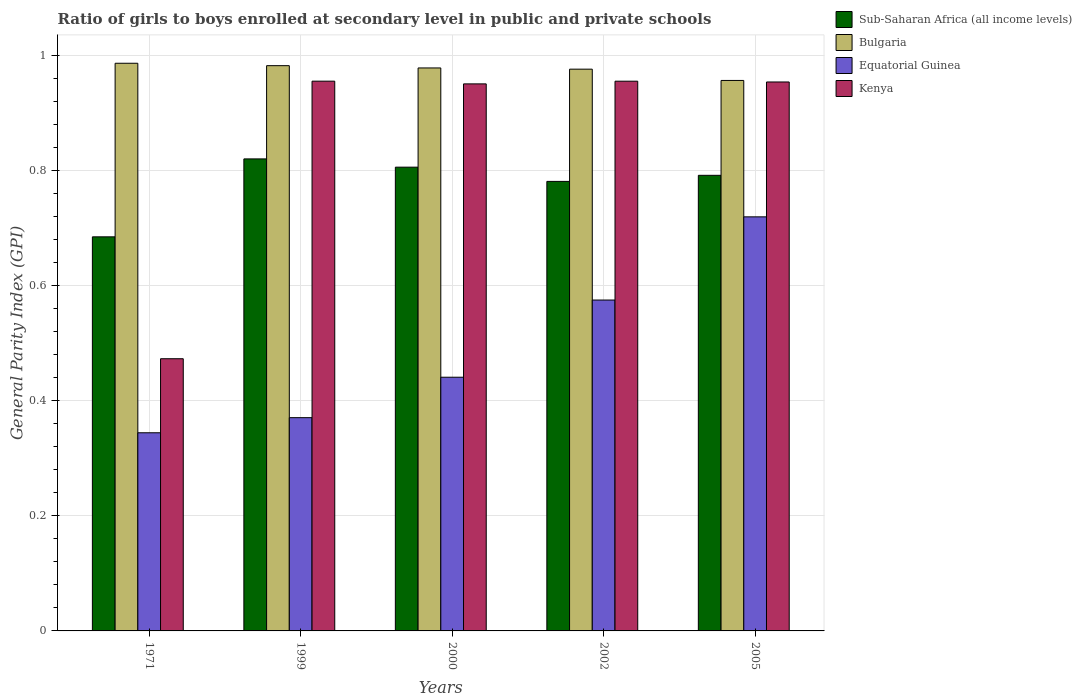Are the number of bars on each tick of the X-axis equal?
Offer a very short reply. Yes. How many bars are there on the 5th tick from the left?
Give a very brief answer. 4. How many bars are there on the 1st tick from the right?
Make the answer very short. 4. In how many cases, is the number of bars for a given year not equal to the number of legend labels?
Your response must be concise. 0. What is the general parity index in Equatorial Guinea in 2002?
Provide a short and direct response. 0.58. Across all years, what is the maximum general parity index in Sub-Saharan Africa (all income levels)?
Your answer should be compact. 0.82. Across all years, what is the minimum general parity index in Sub-Saharan Africa (all income levels)?
Your response must be concise. 0.68. In which year was the general parity index in Bulgaria maximum?
Your answer should be compact. 1971. What is the total general parity index in Kenya in the graph?
Offer a very short reply. 4.29. What is the difference between the general parity index in Sub-Saharan Africa (all income levels) in 1999 and that in 2002?
Ensure brevity in your answer.  0.04. What is the difference between the general parity index in Kenya in 2005 and the general parity index in Equatorial Guinea in 1999?
Keep it short and to the point. 0.58. What is the average general parity index in Kenya per year?
Provide a succinct answer. 0.86. In the year 2005, what is the difference between the general parity index in Bulgaria and general parity index in Sub-Saharan Africa (all income levels)?
Ensure brevity in your answer.  0.16. What is the ratio of the general parity index in Kenya in 2000 to that in 2002?
Your response must be concise. 1. Is the general parity index in Kenya in 2002 less than that in 2005?
Make the answer very short. No. What is the difference between the highest and the second highest general parity index in Sub-Saharan Africa (all income levels)?
Your answer should be compact. 0.01. What is the difference between the highest and the lowest general parity index in Sub-Saharan Africa (all income levels)?
Provide a succinct answer. 0.14. In how many years, is the general parity index in Kenya greater than the average general parity index in Kenya taken over all years?
Provide a succinct answer. 4. Is the sum of the general parity index in Sub-Saharan Africa (all income levels) in 1971 and 2005 greater than the maximum general parity index in Bulgaria across all years?
Keep it short and to the point. Yes. Is it the case that in every year, the sum of the general parity index in Kenya and general parity index in Equatorial Guinea is greater than the sum of general parity index in Bulgaria and general parity index in Sub-Saharan Africa (all income levels)?
Your answer should be compact. No. What does the 3rd bar from the left in 2002 represents?
Keep it short and to the point. Equatorial Guinea. How many bars are there?
Provide a succinct answer. 20. Are all the bars in the graph horizontal?
Your answer should be very brief. No. How many years are there in the graph?
Make the answer very short. 5. What is the difference between two consecutive major ticks on the Y-axis?
Make the answer very short. 0.2. Are the values on the major ticks of Y-axis written in scientific E-notation?
Make the answer very short. No. Does the graph contain any zero values?
Offer a terse response. No. Does the graph contain grids?
Provide a short and direct response. Yes. What is the title of the graph?
Offer a very short reply. Ratio of girls to boys enrolled at secondary level in public and private schools. What is the label or title of the X-axis?
Your response must be concise. Years. What is the label or title of the Y-axis?
Keep it short and to the point. General Parity Index (GPI). What is the General Parity Index (GPI) of Sub-Saharan Africa (all income levels) in 1971?
Ensure brevity in your answer.  0.68. What is the General Parity Index (GPI) in Bulgaria in 1971?
Offer a very short reply. 0.99. What is the General Parity Index (GPI) in Equatorial Guinea in 1971?
Your response must be concise. 0.34. What is the General Parity Index (GPI) in Kenya in 1971?
Ensure brevity in your answer.  0.47. What is the General Parity Index (GPI) of Sub-Saharan Africa (all income levels) in 1999?
Offer a terse response. 0.82. What is the General Parity Index (GPI) of Bulgaria in 1999?
Offer a very short reply. 0.98. What is the General Parity Index (GPI) of Equatorial Guinea in 1999?
Your answer should be compact. 0.37. What is the General Parity Index (GPI) of Kenya in 1999?
Your response must be concise. 0.96. What is the General Parity Index (GPI) of Sub-Saharan Africa (all income levels) in 2000?
Provide a short and direct response. 0.81. What is the General Parity Index (GPI) in Bulgaria in 2000?
Keep it short and to the point. 0.98. What is the General Parity Index (GPI) of Equatorial Guinea in 2000?
Your response must be concise. 0.44. What is the General Parity Index (GPI) in Kenya in 2000?
Provide a succinct answer. 0.95. What is the General Parity Index (GPI) of Sub-Saharan Africa (all income levels) in 2002?
Make the answer very short. 0.78. What is the General Parity Index (GPI) in Bulgaria in 2002?
Ensure brevity in your answer.  0.98. What is the General Parity Index (GPI) in Equatorial Guinea in 2002?
Provide a succinct answer. 0.58. What is the General Parity Index (GPI) of Kenya in 2002?
Give a very brief answer. 0.96. What is the General Parity Index (GPI) of Sub-Saharan Africa (all income levels) in 2005?
Make the answer very short. 0.79. What is the General Parity Index (GPI) of Bulgaria in 2005?
Give a very brief answer. 0.96. What is the General Parity Index (GPI) of Equatorial Guinea in 2005?
Your response must be concise. 0.72. What is the General Parity Index (GPI) of Kenya in 2005?
Make the answer very short. 0.95. Across all years, what is the maximum General Parity Index (GPI) of Sub-Saharan Africa (all income levels)?
Your answer should be compact. 0.82. Across all years, what is the maximum General Parity Index (GPI) of Bulgaria?
Make the answer very short. 0.99. Across all years, what is the maximum General Parity Index (GPI) in Equatorial Guinea?
Make the answer very short. 0.72. Across all years, what is the maximum General Parity Index (GPI) of Kenya?
Your response must be concise. 0.96. Across all years, what is the minimum General Parity Index (GPI) of Sub-Saharan Africa (all income levels)?
Your response must be concise. 0.68. Across all years, what is the minimum General Parity Index (GPI) in Bulgaria?
Give a very brief answer. 0.96. Across all years, what is the minimum General Parity Index (GPI) of Equatorial Guinea?
Ensure brevity in your answer.  0.34. Across all years, what is the minimum General Parity Index (GPI) in Kenya?
Offer a very short reply. 0.47. What is the total General Parity Index (GPI) of Sub-Saharan Africa (all income levels) in the graph?
Your answer should be compact. 3.88. What is the total General Parity Index (GPI) in Bulgaria in the graph?
Offer a terse response. 4.88. What is the total General Parity Index (GPI) of Equatorial Guinea in the graph?
Provide a short and direct response. 2.45. What is the total General Parity Index (GPI) in Kenya in the graph?
Ensure brevity in your answer.  4.29. What is the difference between the General Parity Index (GPI) of Sub-Saharan Africa (all income levels) in 1971 and that in 1999?
Your answer should be very brief. -0.14. What is the difference between the General Parity Index (GPI) in Bulgaria in 1971 and that in 1999?
Your response must be concise. 0. What is the difference between the General Parity Index (GPI) of Equatorial Guinea in 1971 and that in 1999?
Provide a succinct answer. -0.03. What is the difference between the General Parity Index (GPI) of Kenya in 1971 and that in 1999?
Offer a very short reply. -0.48. What is the difference between the General Parity Index (GPI) of Sub-Saharan Africa (all income levels) in 1971 and that in 2000?
Offer a terse response. -0.12. What is the difference between the General Parity Index (GPI) of Bulgaria in 1971 and that in 2000?
Your response must be concise. 0.01. What is the difference between the General Parity Index (GPI) of Equatorial Guinea in 1971 and that in 2000?
Give a very brief answer. -0.1. What is the difference between the General Parity Index (GPI) in Kenya in 1971 and that in 2000?
Keep it short and to the point. -0.48. What is the difference between the General Parity Index (GPI) in Sub-Saharan Africa (all income levels) in 1971 and that in 2002?
Your answer should be very brief. -0.1. What is the difference between the General Parity Index (GPI) of Bulgaria in 1971 and that in 2002?
Your answer should be very brief. 0.01. What is the difference between the General Parity Index (GPI) in Equatorial Guinea in 1971 and that in 2002?
Give a very brief answer. -0.23. What is the difference between the General Parity Index (GPI) of Kenya in 1971 and that in 2002?
Make the answer very short. -0.48. What is the difference between the General Parity Index (GPI) of Sub-Saharan Africa (all income levels) in 1971 and that in 2005?
Your answer should be compact. -0.11. What is the difference between the General Parity Index (GPI) in Bulgaria in 1971 and that in 2005?
Your answer should be compact. 0.03. What is the difference between the General Parity Index (GPI) in Equatorial Guinea in 1971 and that in 2005?
Offer a very short reply. -0.38. What is the difference between the General Parity Index (GPI) in Kenya in 1971 and that in 2005?
Offer a terse response. -0.48. What is the difference between the General Parity Index (GPI) of Sub-Saharan Africa (all income levels) in 1999 and that in 2000?
Make the answer very short. 0.01. What is the difference between the General Parity Index (GPI) of Bulgaria in 1999 and that in 2000?
Provide a succinct answer. 0. What is the difference between the General Parity Index (GPI) of Equatorial Guinea in 1999 and that in 2000?
Ensure brevity in your answer.  -0.07. What is the difference between the General Parity Index (GPI) in Kenya in 1999 and that in 2000?
Keep it short and to the point. 0. What is the difference between the General Parity Index (GPI) in Sub-Saharan Africa (all income levels) in 1999 and that in 2002?
Provide a succinct answer. 0.04. What is the difference between the General Parity Index (GPI) of Bulgaria in 1999 and that in 2002?
Ensure brevity in your answer.  0.01. What is the difference between the General Parity Index (GPI) of Equatorial Guinea in 1999 and that in 2002?
Give a very brief answer. -0.2. What is the difference between the General Parity Index (GPI) of Sub-Saharan Africa (all income levels) in 1999 and that in 2005?
Provide a short and direct response. 0.03. What is the difference between the General Parity Index (GPI) in Bulgaria in 1999 and that in 2005?
Your answer should be compact. 0.03. What is the difference between the General Parity Index (GPI) in Equatorial Guinea in 1999 and that in 2005?
Provide a short and direct response. -0.35. What is the difference between the General Parity Index (GPI) in Kenya in 1999 and that in 2005?
Make the answer very short. 0. What is the difference between the General Parity Index (GPI) in Sub-Saharan Africa (all income levels) in 2000 and that in 2002?
Your answer should be compact. 0.02. What is the difference between the General Parity Index (GPI) of Bulgaria in 2000 and that in 2002?
Ensure brevity in your answer.  0. What is the difference between the General Parity Index (GPI) in Equatorial Guinea in 2000 and that in 2002?
Provide a succinct answer. -0.13. What is the difference between the General Parity Index (GPI) in Kenya in 2000 and that in 2002?
Provide a short and direct response. -0. What is the difference between the General Parity Index (GPI) in Sub-Saharan Africa (all income levels) in 2000 and that in 2005?
Ensure brevity in your answer.  0.01. What is the difference between the General Parity Index (GPI) of Bulgaria in 2000 and that in 2005?
Your answer should be very brief. 0.02. What is the difference between the General Parity Index (GPI) in Equatorial Guinea in 2000 and that in 2005?
Provide a succinct answer. -0.28. What is the difference between the General Parity Index (GPI) of Kenya in 2000 and that in 2005?
Your answer should be very brief. -0. What is the difference between the General Parity Index (GPI) in Sub-Saharan Africa (all income levels) in 2002 and that in 2005?
Your answer should be very brief. -0.01. What is the difference between the General Parity Index (GPI) in Bulgaria in 2002 and that in 2005?
Offer a terse response. 0.02. What is the difference between the General Parity Index (GPI) in Equatorial Guinea in 2002 and that in 2005?
Offer a terse response. -0.14. What is the difference between the General Parity Index (GPI) in Kenya in 2002 and that in 2005?
Your answer should be very brief. 0. What is the difference between the General Parity Index (GPI) of Sub-Saharan Africa (all income levels) in 1971 and the General Parity Index (GPI) of Bulgaria in 1999?
Make the answer very short. -0.3. What is the difference between the General Parity Index (GPI) of Sub-Saharan Africa (all income levels) in 1971 and the General Parity Index (GPI) of Equatorial Guinea in 1999?
Provide a succinct answer. 0.31. What is the difference between the General Parity Index (GPI) in Sub-Saharan Africa (all income levels) in 1971 and the General Parity Index (GPI) in Kenya in 1999?
Your answer should be compact. -0.27. What is the difference between the General Parity Index (GPI) of Bulgaria in 1971 and the General Parity Index (GPI) of Equatorial Guinea in 1999?
Your response must be concise. 0.62. What is the difference between the General Parity Index (GPI) of Bulgaria in 1971 and the General Parity Index (GPI) of Kenya in 1999?
Provide a succinct answer. 0.03. What is the difference between the General Parity Index (GPI) of Equatorial Guinea in 1971 and the General Parity Index (GPI) of Kenya in 1999?
Ensure brevity in your answer.  -0.61. What is the difference between the General Parity Index (GPI) of Sub-Saharan Africa (all income levels) in 1971 and the General Parity Index (GPI) of Bulgaria in 2000?
Your answer should be compact. -0.29. What is the difference between the General Parity Index (GPI) in Sub-Saharan Africa (all income levels) in 1971 and the General Parity Index (GPI) in Equatorial Guinea in 2000?
Offer a very short reply. 0.24. What is the difference between the General Parity Index (GPI) in Sub-Saharan Africa (all income levels) in 1971 and the General Parity Index (GPI) in Kenya in 2000?
Ensure brevity in your answer.  -0.27. What is the difference between the General Parity Index (GPI) in Bulgaria in 1971 and the General Parity Index (GPI) in Equatorial Guinea in 2000?
Make the answer very short. 0.55. What is the difference between the General Parity Index (GPI) of Bulgaria in 1971 and the General Parity Index (GPI) of Kenya in 2000?
Your answer should be very brief. 0.04. What is the difference between the General Parity Index (GPI) in Equatorial Guinea in 1971 and the General Parity Index (GPI) in Kenya in 2000?
Keep it short and to the point. -0.61. What is the difference between the General Parity Index (GPI) of Sub-Saharan Africa (all income levels) in 1971 and the General Parity Index (GPI) of Bulgaria in 2002?
Keep it short and to the point. -0.29. What is the difference between the General Parity Index (GPI) in Sub-Saharan Africa (all income levels) in 1971 and the General Parity Index (GPI) in Equatorial Guinea in 2002?
Keep it short and to the point. 0.11. What is the difference between the General Parity Index (GPI) of Sub-Saharan Africa (all income levels) in 1971 and the General Parity Index (GPI) of Kenya in 2002?
Your response must be concise. -0.27. What is the difference between the General Parity Index (GPI) of Bulgaria in 1971 and the General Parity Index (GPI) of Equatorial Guinea in 2002?
Make the answer very short. 0.41. What is the difference between the General Parity Index (GPI) of Bulgaria in 1971 and the General Parity Index (GPI) of Kenya in 2002?
Provide a succinct answer. 0.03. What is the difference between the General Parity Index (GPI) in Equatorial Guinea in 1971 and the General Parity Index (GPI) in Kenya in 2002?
Ensure brevity in your answer.  -0.61. What is the difference between the General Parity Index (GPI) in Sub-Saharan Africa (all income levels) in 1971 and the General Parity Index (GPI) in Bulgaria in 2005?
Provide a short and direct response. -0.27. What is the difference between the General Parity Index (GPI) of Sub-Saharan Africa (all income levels) in 1971 and the General Parity Index (GPI) of Equatorial Guinea in 2005?
Offer a terse response. -0.03. What is the difference between the General Parity Index (GPI) in Sub-Saharan Africa (all income levels) in 1971 and the General Parity Index (GPI) in Kenya in 2005?
Your response must be concise. -0.27. What is the difference between the General Parity Index (GPI) in Bulgaria in 1971 and the General Parity Index (GPI) in Equatorial Guinea in 2005?
Keep it short and to the point. 0.27. What is the difference between the General Parity Index (GPI) of Bulgaria in 1971 and the General Parity Index (GPI) of Kenya in 2005?
Your answer should be very brief. 0.03. What is the difference between the General Parity Index (GPI) of Equatorial Guinea in 1971 and the General Parity Index (GPI) of Kenya in 2005?
Provide a succinct answer. -0.61. What is the difference between the General Parity Index (GPI) in Sub-Saharan Africa (all income levels) in 1999 and the General Parity Index (GPI) in Bulgaria in 2000?
Your answer should be very brief. -0.16. What is the difference between the General Parity Index (GPI) in Sub-Saharan Africa (all income levels) in 1999 and the General Parity Index (GPI) in Equatorial Guinea in 2000?
Offer a terse response. 0.38. What is the difference between the General Parity Index (GPI) in Sub-Saharan Africa (all income levels) in 1999 and the General Parity Index (GPI) in Kenya in 2000?
Ensure brevity in your answer.  -0.13. What is the difference between the General Parity Index (GPI) of Bulgaria in 1999 and the General Parity Index (GPI) of Equatorial Guinea in 2000?
Provide a short and direct response. 0.54. What is the difference between the General Parity Index (GPI) of Bulgaria in 1999 and the General Parity Index (GPI) of Kenya in 2000?
Your response must be concise. 0.03. What is the difference between the General Parity Index (GPI) of Equatorial Guinea in 1999 and the General Parity Index (GPI) of Kenya in 2000?
Ensure brevity in your answer.  -0.58. What is the difference between the General Parity Index (GPI) of Sub-Saharan Africa (all income levels) in 1999 and the General Parity Index (GPI) of Bulgaria in 2002?
Your answer should be compact. -0.16. What is the difference between the General Parity Index (GPI) of Sub-Saharan Africa (all income levels) in 1999 and the General Parity Index (GPI) of Equatorial Guinea in 2002?
Provide a succinct answer. 0.25. What is the difference between the General Parity Index (GPI) of Sub-Saharan Africa (all income levels) in 1999 and the General Parity Index (GPI) of Kenya in 2002?
Your answer should be very brief. -0.14. What is the difference between the General Parity Index (GPI) of Bulgaria in 1999 and the General Parity Index (GPI) of Equatorial Guinea in 2002?
Provide a succinct answer. 0.41. What is the difference between the General Parity Index (GPI) in Bulgaria in 1999 and the General Parity Index (GPI) in Kenya in 2002?
Your response must be concise. 0.03. What is the difference between the General Parity Index (GPI) in Equatorial Guinea in 1999 and the General Parity Index (GPI) in Kenya in 2002?
Provide a short and direct response. -0.58. What is the difference between the General Parity Index (GPI) of Sub-Saharan Africa (all income levels) in 1999 and the General Parity Index (GPI) of Bulgaria in 2005?
Give a very brief answer. -0.14. What is the difference between the General Parity Index (GPI) of Sub-Saharan Africa (all income levels) in 1999 and the General Parity Index (GPI) of Equatorial Guinea in 2005?
Keep it short and to the point. 0.1. What is the difference between the General Parity Index (GPI) of Sub-Saharan Africa (all income levels) in 1999 and the General Parity Index (GPI) of Kenya in 2005?
Make the answer very short. -0.13. What is the difference between the General Parity Index (GPI) of Bulgaria in 1999 and the General Parity Index (GPI) of Equatorial Guinea in 2005?
Your response must be concise. 0.26. What is the difference between the General Parity Index (GPI) of Bulgaria in 1999 and the General Parity Index (GPI) of Kenya in 2005?
Give a very brief answer. 0.03. What is the difference between the General Parity Index (GPI) in Equatorial Guinea in 1999 and the General Parity Index (GPI) in Kenya in 2005?
Keep it short and to the point. -0.58. What is the difference between the General Parity Index (GPI) of Sub-Saharan Africa (all income levels) in 2000 and the General Parity Index (GPI) of Bulgaria in 2002?
Make the answer very short. -0.17. What is the difference between the General Parity Index (GPI) of Sub-Saharan Africa (all income levels) in 2000 and the General Parity Index (GPI) of Equatorial Guinea in 2002?
Offer a very short reply. 0.23. What is the difference between the General Parity Index (GPI) in Sub-Saharan Africa (all income levels) in 2000 and the General Parity Index (GPI) in Kenya in 2002?
Your answer should be compact. -0.15. What is the difference between the General Parity Index (GPI) in Bulgaria in 2000 and the General Parity Index (GPI) in Equatorial Guinea in 2002?
Provide a short and direct response. 0.4. What is the difference between the General Parity Index (GPI) in Bulgaria in 2000 and the General Parity Index (GPI) in Kenya in 2002?
Offer a very short reply. 0.02. What is the difference between the General Parity Index (GPI) of Equatorial Guinea in 2000 and the General Parity Index (GPI) of Kenya in 2002?
Keep it short and to the point. -0.51. What is the difference between the General Parity Index (GPI) in Sub-Saharan Africa (all income levels) in 2000 and the General Parity Index (GPI) in Bulgaria in 2005?
Offer a very short reply. -0.15. What is the difference between the General Parity Index (GPI) of Sub-Saharan Africa (all income levels) in 2000 and the General Parity Index (GPI) of Equatorial Guinea in 2005?
Ensure brevity in your answer.  0.09. What is the difference between the General Parity Index (GPI) in Sub-Saharan Africa (all income levels) in 2000 and the General Parity Index (GPI) in Kenya in 2005?
Ensure brevity in your answer.  -0.15. What is the difference between the General Parity Index (GPI) in Bulgaria in 2000 and the General Parity Index (GPI) in Equatorial Guinea in 2005?
Your answer should be compact. 0.26. What is the difference between the General Parity Index (GPI) of Bulgaria in 2000 and the General Parity Index (GPI) of Kenya in 2005?
Offer a terse response. 0.02. What is the difference between the General Parity Index (GPI) in Equatorial Guinea in 2000 and the General Parity Index (GPI) in Kenya in 2005?
Make the answer very short. -0.51. What is the difference between the General Parity Index (GPI) of Sub-Saharan Africa (all income levels) in 2002 and the General Parity Index (GPI) of Bulgaria in 2005?
Make the answer very short. -0.18. What is the difference between the General Parity Index (GPI) of Sub-Saharan Africa (all income levels) in 2002 and the General Parity Index (GPI) of Equatorial Guinea in 2005?
Offer a very short reply. 0.06. What is the difference between the General Parity Index (GPI) of Sub-Saharan Africa (all income levels) in 2002 and the General Parity Index (GPI) of Kenya in 2005?
Your answer should be compact. -0.17. What is the difference between the General Parity Index (GPI) of Bulgaria in 2002 and the General Parity Index (GPI) of Equatorial Guinea in 2005?
Ensure brevity in your answer.  0.26. What is the difference between the General Parity Index (GPI) in Bulgaria in 2002 and the General Parity Index (GPI) in Kenya in 2005?
Provide a succinct answer. 0.02. What is the difference between the General Parity Index (GPI) of Equatorial Guinea in 2002 and the General Parity Index (GPI) of Kenya in 2005?
Offer a terse response. -0.38. What is the average General Parity Index (GPI) in Sub-Saharan Africa (all income levels) per year?
Your answer should be compact. 0.78. What is the average General Parity Index (GPI) of Bulgaria per year?
Your answer should be very brief. 0.98. What is the average General Parity Index (GPI) of Equatorial Guinea per year?
Offer a terse response. 0.49. What is the average General Parity Index (GPI) of Kenya per year?
Provide a succinct answer. 0.86. In the year 1971, what is the difference between the General Parity Index (GPI) of Sub-Saharan Africa (all income levels) and General Parity Index (GPI) of Bulgaria?
Offer a terse response. -0.3. In the year 1971, what is the difference between the General Parity Index (GPI) in Sub-Saharan Africa (all income levels) and General Parity Index (GPI) in Equatorial Guinea?
Offer a terse response. 0.34. In the year 1971, what is the difference between the General Parity Index (GPI) in Sub-Saharan Africa (all income levels) and General Parity Index (GPI) in Kenya?
Make the answer very short. 0.21. In the year 1971, what is the difference between the General Parity Index (GPI) in Bulgaria and General Parity Index (GPI) in Equatorial Guinea?
Offer a very short reply. 0.64. In the year 1971, what is the difference between the General Parity Index (GPI) in Bulgaria and General Parity Index (GPI) in Kenya?
Make the answer very short. 0.51. In the year 1971, what is the difference between the General Parity Index (GPI) in Equatorial Guinea and General Parity Index (GPI) in Kenya?
Your response must be concise. -0.13. In the year 1999, what is the difference between the General Parity Index (GPI) of Sub-Saharan Africa (all income levels) and General Parity Index (GPI) of Bulgaria?
Your answer should be very brief. -0.16. In the year 1999, what is the difference between the General Parity Index (GPI) of Sub-Saharan Africa (all income levels) and General Parity Index (GPI) of Equatorial Guinea?
Provide a succinct answer. 0.45. In the year 1999, what is the difference between the General Parity Index (GPI) of Sub-Saharan Africa (all income levels) and General Parity Index (GPI) of Kenya?
Provide a short and direct response. -0.14. In the year 1999, what is the difference between the General Parity Index (GPI) of Bulgaria and General Parity Index (GPI) of Equatorial Guinea?
Your response must be concise. 0.61. In the year 1999, what is the difference between the General Parity Index (GPI) of Bulgaria and General Parity Index (GPI) of Kenya?
Your answer should be very brief. 0.03. In the year 1999, what is the difference between the General Parity Index (GPI) in Equatorial Guinea and General Parity Index (GPI) in Kenya?
Offer a very short reply. -0.58. In the year 2000, what is the difference between the General Parity Index (GPI) of Sub-Saharan Africa (all income levels) and General Parity Index (GPI) of Bulgaria?
Offer a very short reply. -0.17. In the year 2000, what is the difference between the General Parity Index (GPI) in Sub-Saharan Africa (all income levels) and General Parity Index (GPI) in Equatorial Guinea?
Offer a terse response. 0.37. In the year 2000, what is the difference between the General Parity Index (GPI) in Sub-Saharan Africa (all income levels) and General Parity Index (GPI) in Kenya?
Your answer should be very brief. -0.14. In the year 2000, what is the difference between the General Parity Index (GPI) of Bulgaria and General Parity Index (GPI) of Equatorial Guinea?
Provide a short and direct response. 0.54. In the year 2000, what is the difference between the General Parity Index (GPI) of Bulgaria and General Parity Index (GPI) of Kenya?
Provide a short and direct response. 0.03. In the year 2000, what is the difference between the General Parity Index (GPI) of Equatorial Guinea and General Parity Index (GPI) of Kenya?
Make the answer very short. -0.51. In the year 2002, what is the difference between the General Parity Index (GPI) of Sub-Saharan Africa (all income levels) and General Parity Index (GPI) of Bulgaria?
Offer a very short reply. -0.2. In the year 2002, what is the difference between the General Parity Index (GPI) in Sub-Saharan Africa (all income levels) and General Parity Index (GPI) in Equatorial Guinea?
Your answer should be compact. 0.21. In the year 2002, what is the difference between the General Parity Index (GPI) of Sub-Saharan Africa (all income levels) and General Parity Index (GPI) of Kenya?
Make the answer very short. -0.17. In the year 2002, what is the difference between the General Parity Index (GPI) of Bulgaria and General Parity Index (GPI) of Equatorial Guinea?
Ensure brevity in your answer.  0.4. In the year 2002, what is the difference between the General Parity Index (GPI) in Bulgaria and General Parity Index (GPI) in Kenya?
Your response must be concise. 0.02. In the year 2002, what is the difference between the General Parity Index (GPI) in Equatorial Guinea and General Parity Index (GPI) in Kenya?
Keep it short and to the point. -0.38. In the year 2005, what is the difference between the General Parity Index (GPI) in Sub-Saharan Africa (all income levels) and General Parity Index (GPI) in Bulgaria?
Keep it short and to the point. -0.16. In the year 2005, what is the difference between the General Parity Index (GPI) of Sub-Saharan Africa (all income levels) and General Parity Index (GPI) of Equatorial Guinea?
Your answer should be very brief. 0.07. In the year 2005, what is the difference between the General Parity Index (GPI) of Sub-Saharan Africa (all income levels) and General Parity Index (GPI) of Kenya?
Make the answer very short. -0.16. In the year 2005, what is the difference between the General Parity Index (GPI) in Bulgaria and General Parity Index (GPI) in Equatorial Guinea?
Your response must be concise. 0.24. In the year 2005, what is the difference between the General Parity Index (GPI) of Bulgaria and General Parity Index (GPI) of Kenya?
Ensure brevity in your answer.  0. In the year 2005, what is the difference between the General Parity Index (GPI) in Equatorial Guinea and General Parity Index (GPI) in Kenya?
Ensure brevity in your answer.  -0.23. What is the ratio of the General Parity Index (GPI) in Sub-Saharan Africa (all income levels) in 1971 to that in 1999?
Keep it short and to the point. 0.83. What is the ratio of the General Parity Index (GPI) of Bulgaria in 1971 to that in 1999?
Give a very brief answer. 1. What is the ratio of the General Parity Index (GPI) of Equatorial Guinea in 1971 to that in 1999?
Provide a succinct answer. 0.93. What is the ratio of the General Parity Index (GPI) of Kenya in 1971 to that in 1999?
Offer a very short reply. 0.5. What is the ratio of the General Parity Index (GPI) in Sub-Saharan Africa (all income levels) in 1971 to that in 2000?
Give a very brief answer. 0.85. What is the ratio of the General Parity Index (GPI) in Bulgaria in 1971 to that in 2000?
Provide a succinct answer. 1.01. What is the ratio of the General Parity Index (GPI) of Equatorial Guinea in 1971 to that in 2000?
Your answer should be very brief. 0.78. What is the ratio of the General Parity Index (GPI) in Kenya in 1971 to that in 2000?
Offer a terse response. 0.5. What is the ratio of the General Parity Index (GPI) in Sub-Saharan Africa (all income levels) in 1971 to that in 2002?
Your answer should be very brief. 0.88. What is the ratio of the General Parity Index (GPI) in Bulgaria in 1971 to that in 2002?
Keep it short and to the point. 1.01. What is the ratio of the General Parity Index (GPI) of Equatorial Guinea in 1971 to that in 2002?
Make the answer very short. 0.6. What is the ratio of the General Parity Index (GPI) of Kenya in 1971 to that in 2002?
Keep it short and to the point. 0.5. What is the ratio of the General Parity Index (GPI) of Sub-Saharan Africa (all income levels) in 1971 to that in 2005?
Your answer should be compact. 0.86. What is the ratio of the General Parity Index (GPI) in Bulgaria in 1971 to that in 2005?
Your response must be concise. 1.03. What is the ratio of the General Parity Index (GPI) in Equatorial Guinea in 1971 to that in 2005?
Your answer should be compact. 0.48. What is the ratio of the General Parity Index (GPI) in Kenya in 1971 to that in 2005?
Provide a succinct answer. 0.5. What is the ratio of the General Parity Index (GPI) of Sub-Saharan Africa (all income levels) in 1999 to that in 2000?
Provide a succinct answer. 1.02. What is the ratio of the General Parity Index (GPI) of Equatorial Guinea in 1999 to that in 2000?
Ensure brevity in your answer.  0.84. What is the ratio of the General Parity Index (GPI) in Bulgaria in 1999 to that in 2002?
Ensure brevity in your answer.  1.01. What is the ratio of the General Parity Index (GPI) in Equatorial Guinea in 1999 to that in 2002?
Give a very brief answer. 0.64. What is the ratio of the General Parity Index (GPI) of Sub-Saharan Africa (all income levels) in 1999 to that in 2005?
Provide a succinct answer. 1.04. What is the ratio of the General Parity Index (GPI) of Bulgaria in 1999 to that in 2005?
Offer a terse response. 1.03. What is the ratio of the General Parity Index (GPI) in Equatorial Guinea in 1999 to that in 2005?
Your response must be concise. 0.52. What is the ratio of the General Parity Index (GPI) of Sub-Saharan Africa (all income levels) in 2000 to that in 2002?
Your response must be concise. 1.03. What is the ratio of the General Parity Index (GPI) of Bulgaria in 2000 to that in 2002?
Provide a succinct answer. 1. What is the ratio of the General Parity Index (GPI) in Equatorial Guinea in 2000 to that in 2002?
Make the answer very short. 0.77. What is the ratio of the General Parity Index (GPI) in Kenya in 2000 to that in 2002?
Provide a short and direct response. 1. What is the ratio of the General Parity Index (GPI) of Sub-Saharan Africa (all income levels) in 2000 to that in 2005?
Your answer should be very brief. 1.02. What is the ratio of the General Parity Index (GPI) in Bulgaria in 2000 to that in 2005?
Offer a very short reply. 1.02. What is the ratio of the General Parity Index (GPI) of Equatorial Guinea in 2000 to that in 2005?
Offer a very short reply. 0.61. What is the ratio of the General Parity Index (GPI) of Kenya in 2000 to that in 2005?
Give a very brief answer. 1. What is the ratio of the General Parity Index (GPI) of Sub-Saharan Africa (all income levels) in 2002 to that in 2005?
Your answer should be very brief. 0.99. What is the ratio of the General Parity Index (GPI) in Bulgaria in 2002 to that in 2005?
Your answer should be compact. 1.02. What is the ratio of the General Parity Index (GPI) in Equatorial Guinea in 2002 to that in 2005?
Your answer should be compact. 0.8. What is the difference between the highest and the second highest General Parity Index (GPI) in Sub-Saharan Africa (all income levels)?
Make the answer very short. 0.01. What is the difference between the highest and the second highest General Parity Index (GPI) of Bulgaria?
Your answer should be very brief. 0. What is the difference between the highest and the second highest General Parity Index (GPI) in Equatorial Guinea?
Ensure brevity in your answer.  0.14. What is the difference between the highest and the lowest General Parity Index (GPI) of Sub-Saharan Africa (all income levels)?
Keep it short and to the point. 0.14. What is the difference between the highest and the lowest General Parity Index (GPI) in Bulgaria?
Provide a short and direct response. 0.03. What is the difference between the highest and the lowest General Parity Index (GPI) in Equatorial Guinea?
Ensure brevity in your answer.  0.38. What is the difference between the highest and the lowest General Parity Index (GPI) of Kenya?
Your answer should be compact. 0.48. 